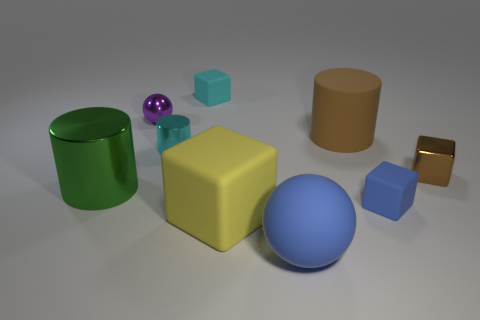There is a cylinder on the left side of the tiny cyan metallic cylinder; what is its color?
Your response must be concise. Green. How big is the cyan block?
Your answer should be very brief. Small. Is the size of the yellow cube the same as the sphere behind the big rubber sphere?
Give a very brief answer. No. There is a tiny thing behind the sphere that is left of the tiny cyan thing in front of the purple metallic thing; what is its color?
Your answer should be compact. Cyan. Are the brown thing that is left of the brown metal block and the big blue thing made of the same material?
Provide a short and direct response. Yes. What number of other objects are there of the same material as the small cylinder?
Offer a terse response. 3. What material is the ball that is the same size as the yellow thing?
Your answer should be compact. Rubber. There is a tiny shiny thing that is to the right of the brown rubber thing; is it the same shape as the green metal object that is in front of the tiny cyan cylinder?
Provide a short and direct response. No. There is a brown matte thing that is the same size as the yellow cube; what shape is it?
Ensure brevity in your answer.  Cylinder. Is the small block in front of the large green metallic thing made of the same material as the block that is behind the purple sphere?
Your response must be concise. Yes. 